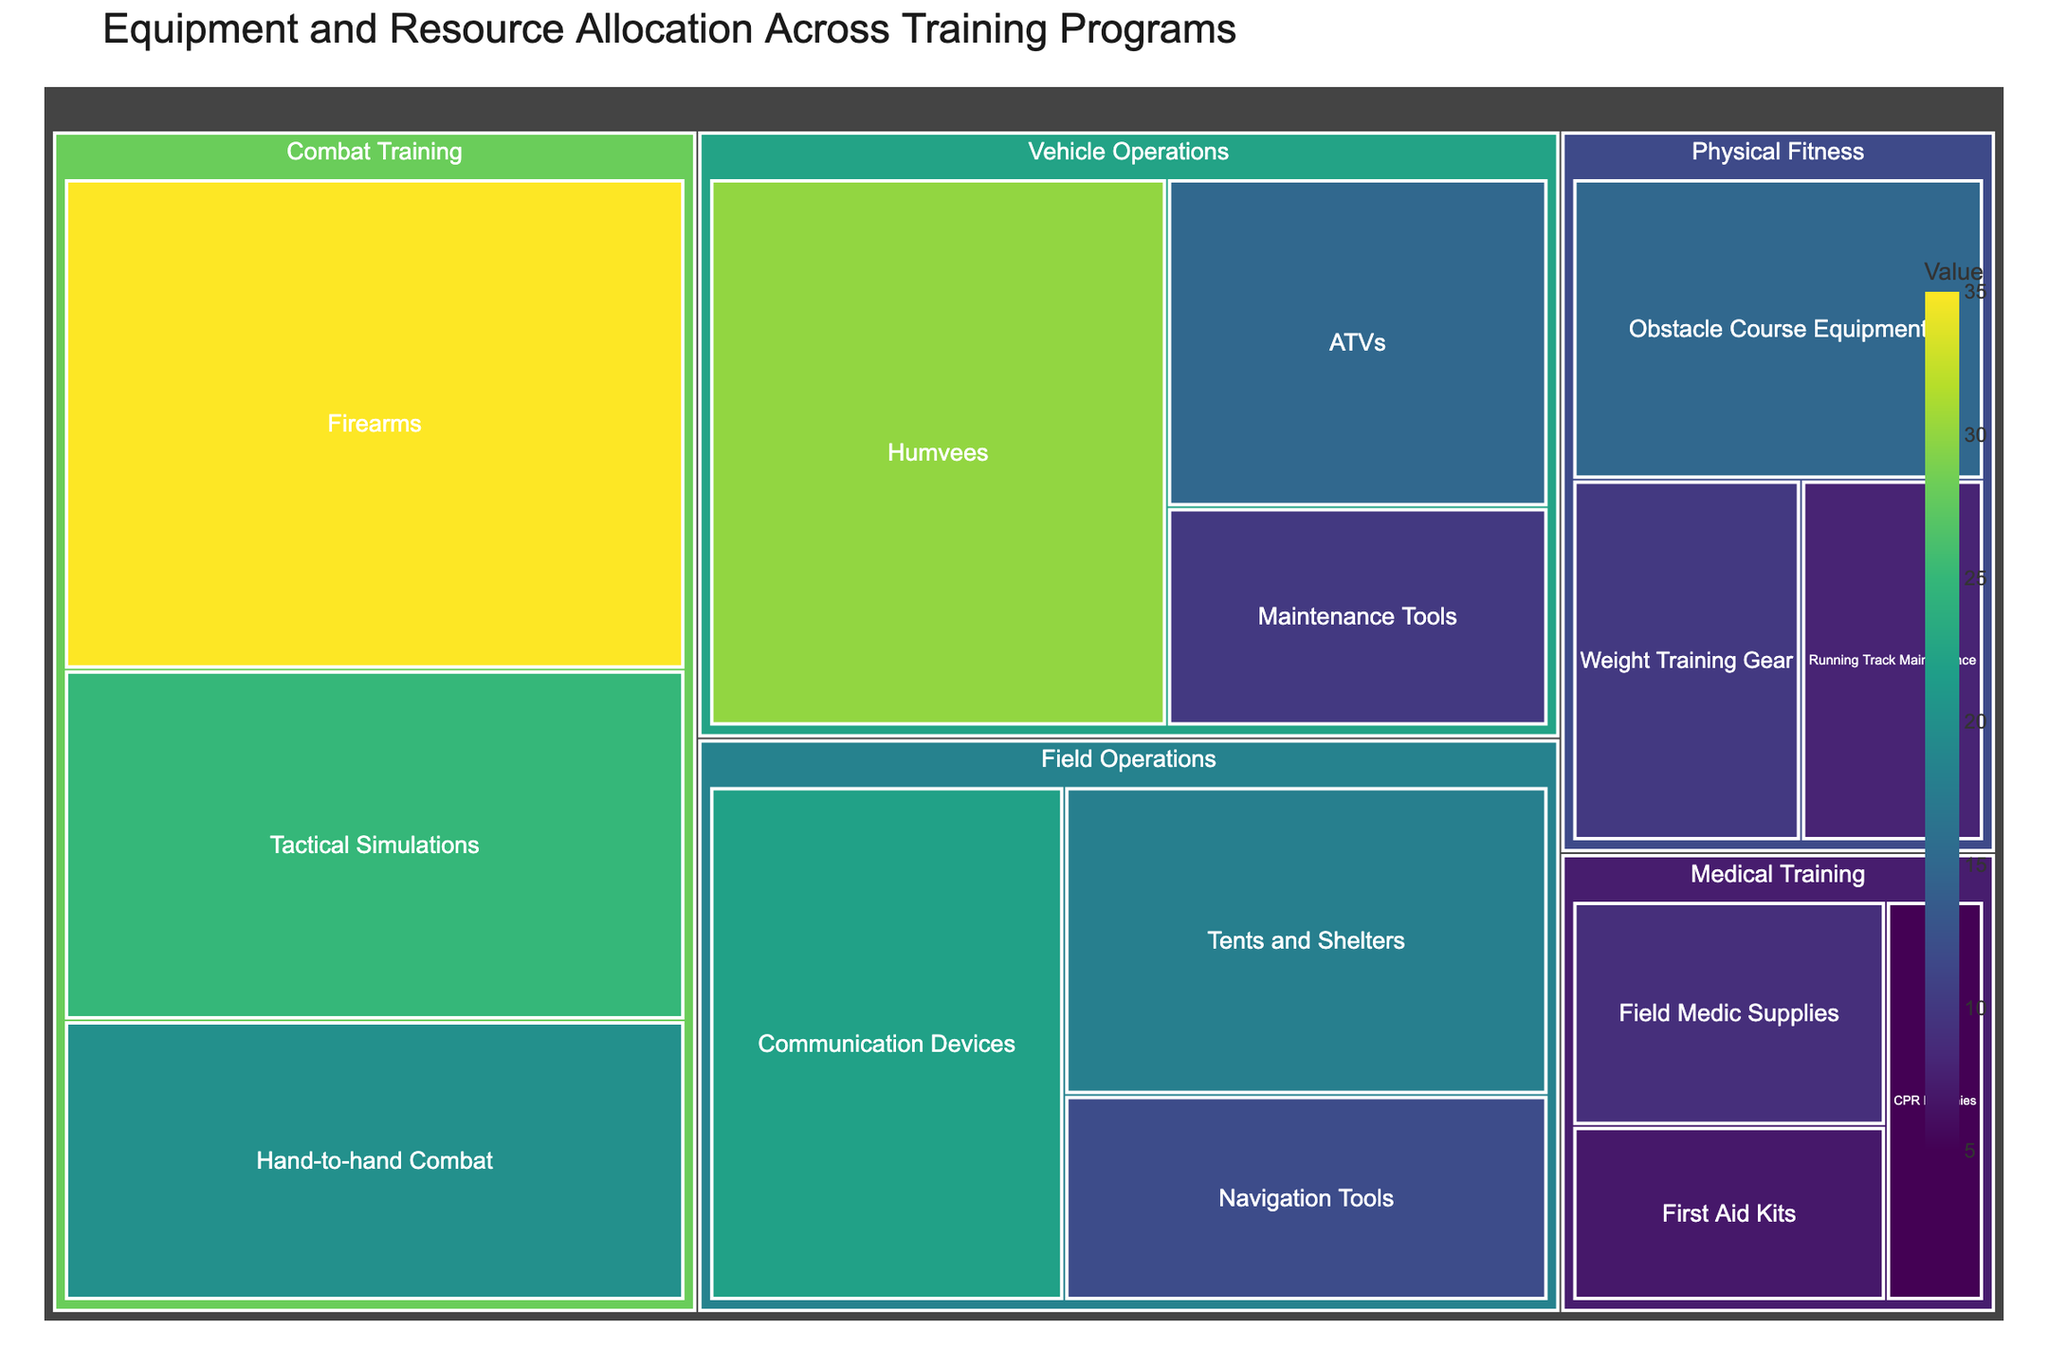what is the title of the figure? The title of the figure is located at the upper part of the figure, providing a summary of the chart content.
Answer: Equipment and Resource Allocation Across Training Programs How many main categories are there? There are four main categories displayed in the figure, which can be seen as the largest blocks within the Treemap.
Answer: Four Which subcategory has the highest value in "Combat Training"? The value of each subcategory in "Combat Training" can be seen within the Combat Training block. The one with the highest value is the largest.
Answer: Firearms What is the combined value of all subcategories under "Vehicle Operations"? To find the combined value, add the values of all subcategories under "Vehicle Operations": 30 (Humvees) + 15 (ATVs) + 10 (Maintenance Tools).
Answer: 55 Which main category has the smallest total allocation value? Compare the area sizes and summed values of all subcategories within each main category. The one with the smallest overall area and summed values is the answer.
Answer: Medical Training How much greater is the value of "Communication Devices" compared to "Navigation Tools" in Field Operations? Subtract the value of Navigation Tools (12) from the value of Communication Devices (22).
Answer: 10 What is the average value of the subcategories under "Physical Fitness"? Add the values of all subcategories under "Physical Fitness" (15 + 10 + 8) and divide by the number of subcategories (3). The sum is 33, and the average is 33/3.
Answer: 11 Which main category has the largest single subcategory value, and what is that value? Look for the largest single subcategory block in the entire Treemap; the category containing this block is the answer.
Answer: Combat Training, 35 What is the difference in the total values between the "Combat Training" and "Medical Training" categories? Sum the values of subcategories in both categories. Combat Training has values of 35, 20, and 25, giving a total of 80. Medical Training has values of 7, 5, and 9, giving a total of 21. The difference is 80 - 21.
Answer: 59 What proportion of the total value does the "Obstacle Course Equipment" under Physical Fitness make up? To find the proportion, take the value of Obstacle Course Equipment (15) and divide by the total of all values, then multiply by 100. The total value of all subcategories is 35 + 20 + 25 + 15 + 10 + 8 + 18 + 12 + 22 + 7 + 5 + 9 + 30 + 15 + 10 = 261. The proportion is (15/261) * 100.
Answer: 5.75% 